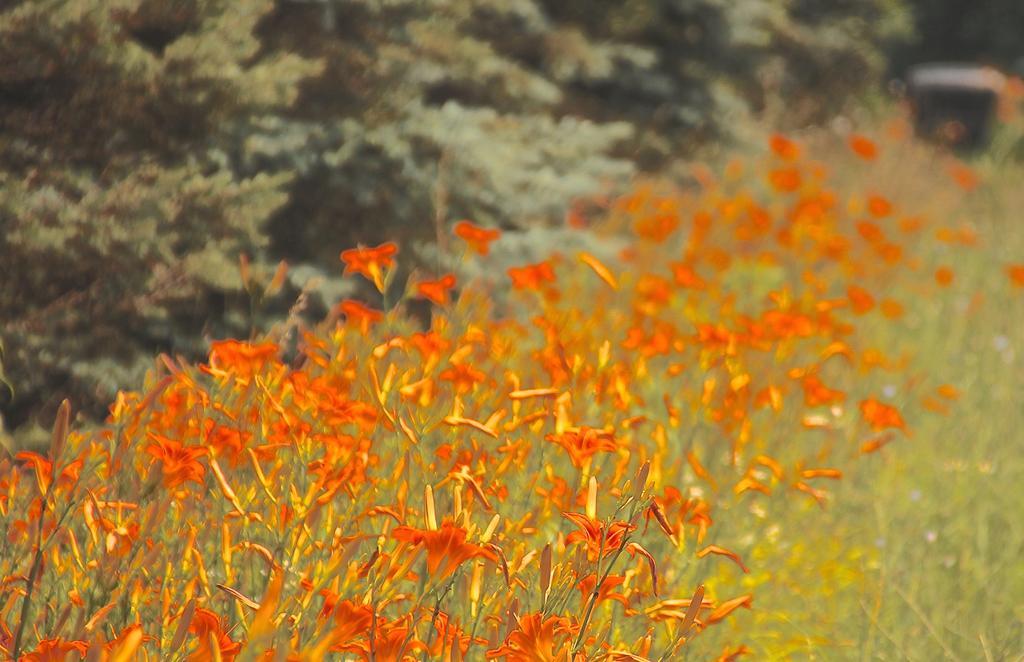Could you give a brief overview of what you see in this image? In this picture we can see plants with flowers and in the background we can see trees and an object and it is blurry. 